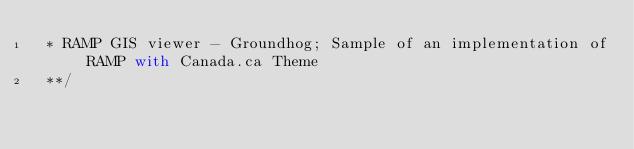Convert code to text. <code><loc_0><loc_0><loc_500><loc_500><_JavaScript_> * RAMP GIS viewer - Groundhog; Sample of an implementation of RAMP with Canada.ca Theme 
 **/</code> 